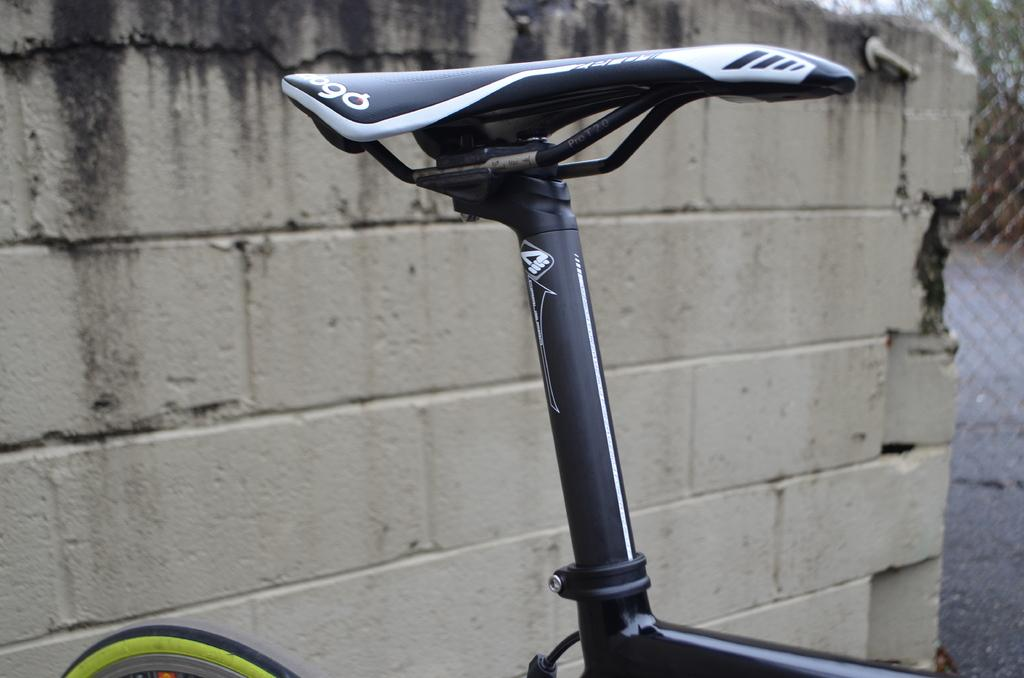What object is the main focus of the image? The main focus of the image is the seat of a bicycle. Can you describe the background of the image? There is a wall visible in the background of the image. How many bridges can be seen in the image? There are no bridges present in the image. What type of fork is being used to blow up the balloon in the image? There is no fork or balloon present in the image. 